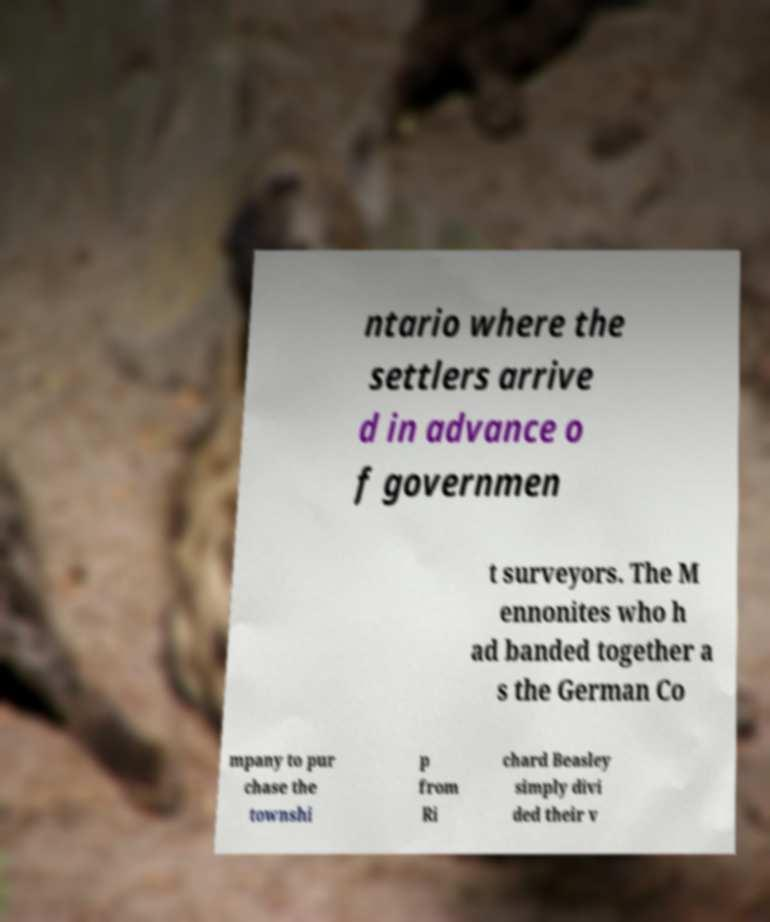Please read and relay the text visible in this image. What does it say? ntario where the settlers arrive d in advance o f governmen t surveyors. The M ennonites who h ad banded together a s the German Co mpany to pur chase the townshi p from Ri chard Beasley simply divi ded their v 